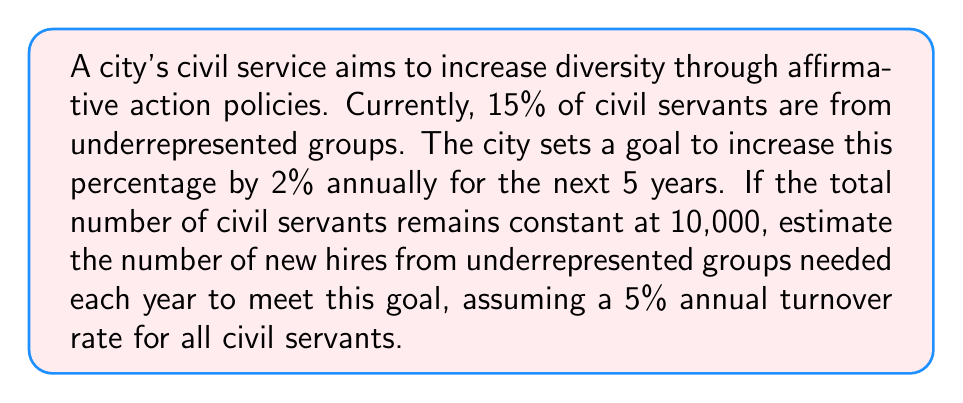Help me with this question. Let's approach this step-by-step:

1) First, let's define our variables:
   $x$ = number of new hires from underrepresented groups needed each year
   $y$ = number of underrepresented civil servants leaving each year due to turnover

2) Current number of underrepresented civil servants:
   $0.15 \times 10,000 = 1,500$

3) Target increase per year:
   $2\% \times 10,000 = 200$

4) Turnover rate for underrepresented civil servants:
   $y = 5\% \times 1,500 = 75$

5) To meet the goal, we need:
   $x - y = 200$

6) Substituting the value of $y$:
   $x - 75 = 200$

7) Solving for $x$:
   $x = 200 + 75 = 275$

Therefore, 275 new hires from underrepresented groups are needed each year to meet the goal.

8) Let's verify this maintains the 2% annual increase:
   Year 1: $(1,500 + 275 - 75) / 10,000 = 17\%$
   Year 2: $(1,700 + 275 - 85) / 10,000 = 19\%$
   Year 3: $(1,890 + 275 - 94.5) / 10,000 = 21\%$
   Year 4: $(2,070.5 + 275 - 103.525) / 10,000 = 23\%$
   Year 5: $(2,241.975 + 275 - 112.09875) / 10,000 = 25\%$

This confirms that the 2% annual increase is maintained.
Answer: 275 new hires per year 